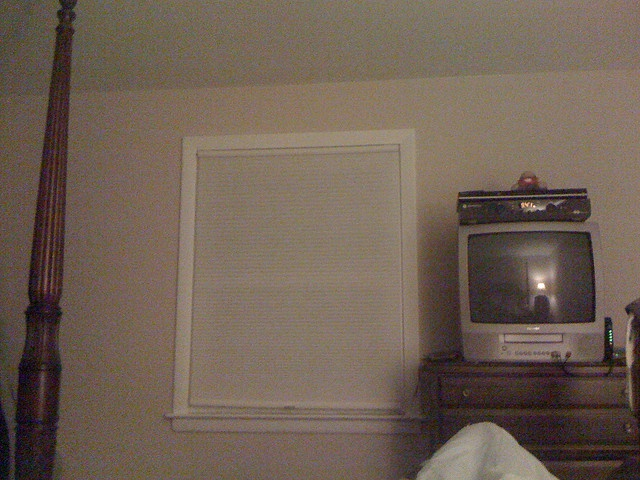Describe the objects in this image and their specific colors. I can see a tv in purple, gray, and black tones in this image. 